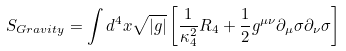Convert formula to latex. <formula><loc_0><loc_0><loc_500><loc_500>S _ { G r a v i t y } = \int d ^ { 4 } x \sqrt { | g | } \left [ \frac { 1 } { \kappa _ { 4 } ^ { 2 } } R _ { 4 } + \frac { 1 } { 2 } g ^ { \mu \nu } \partial _ { \mu } \sigma \partial _ { \nu } \sigma \right ]</formula> 